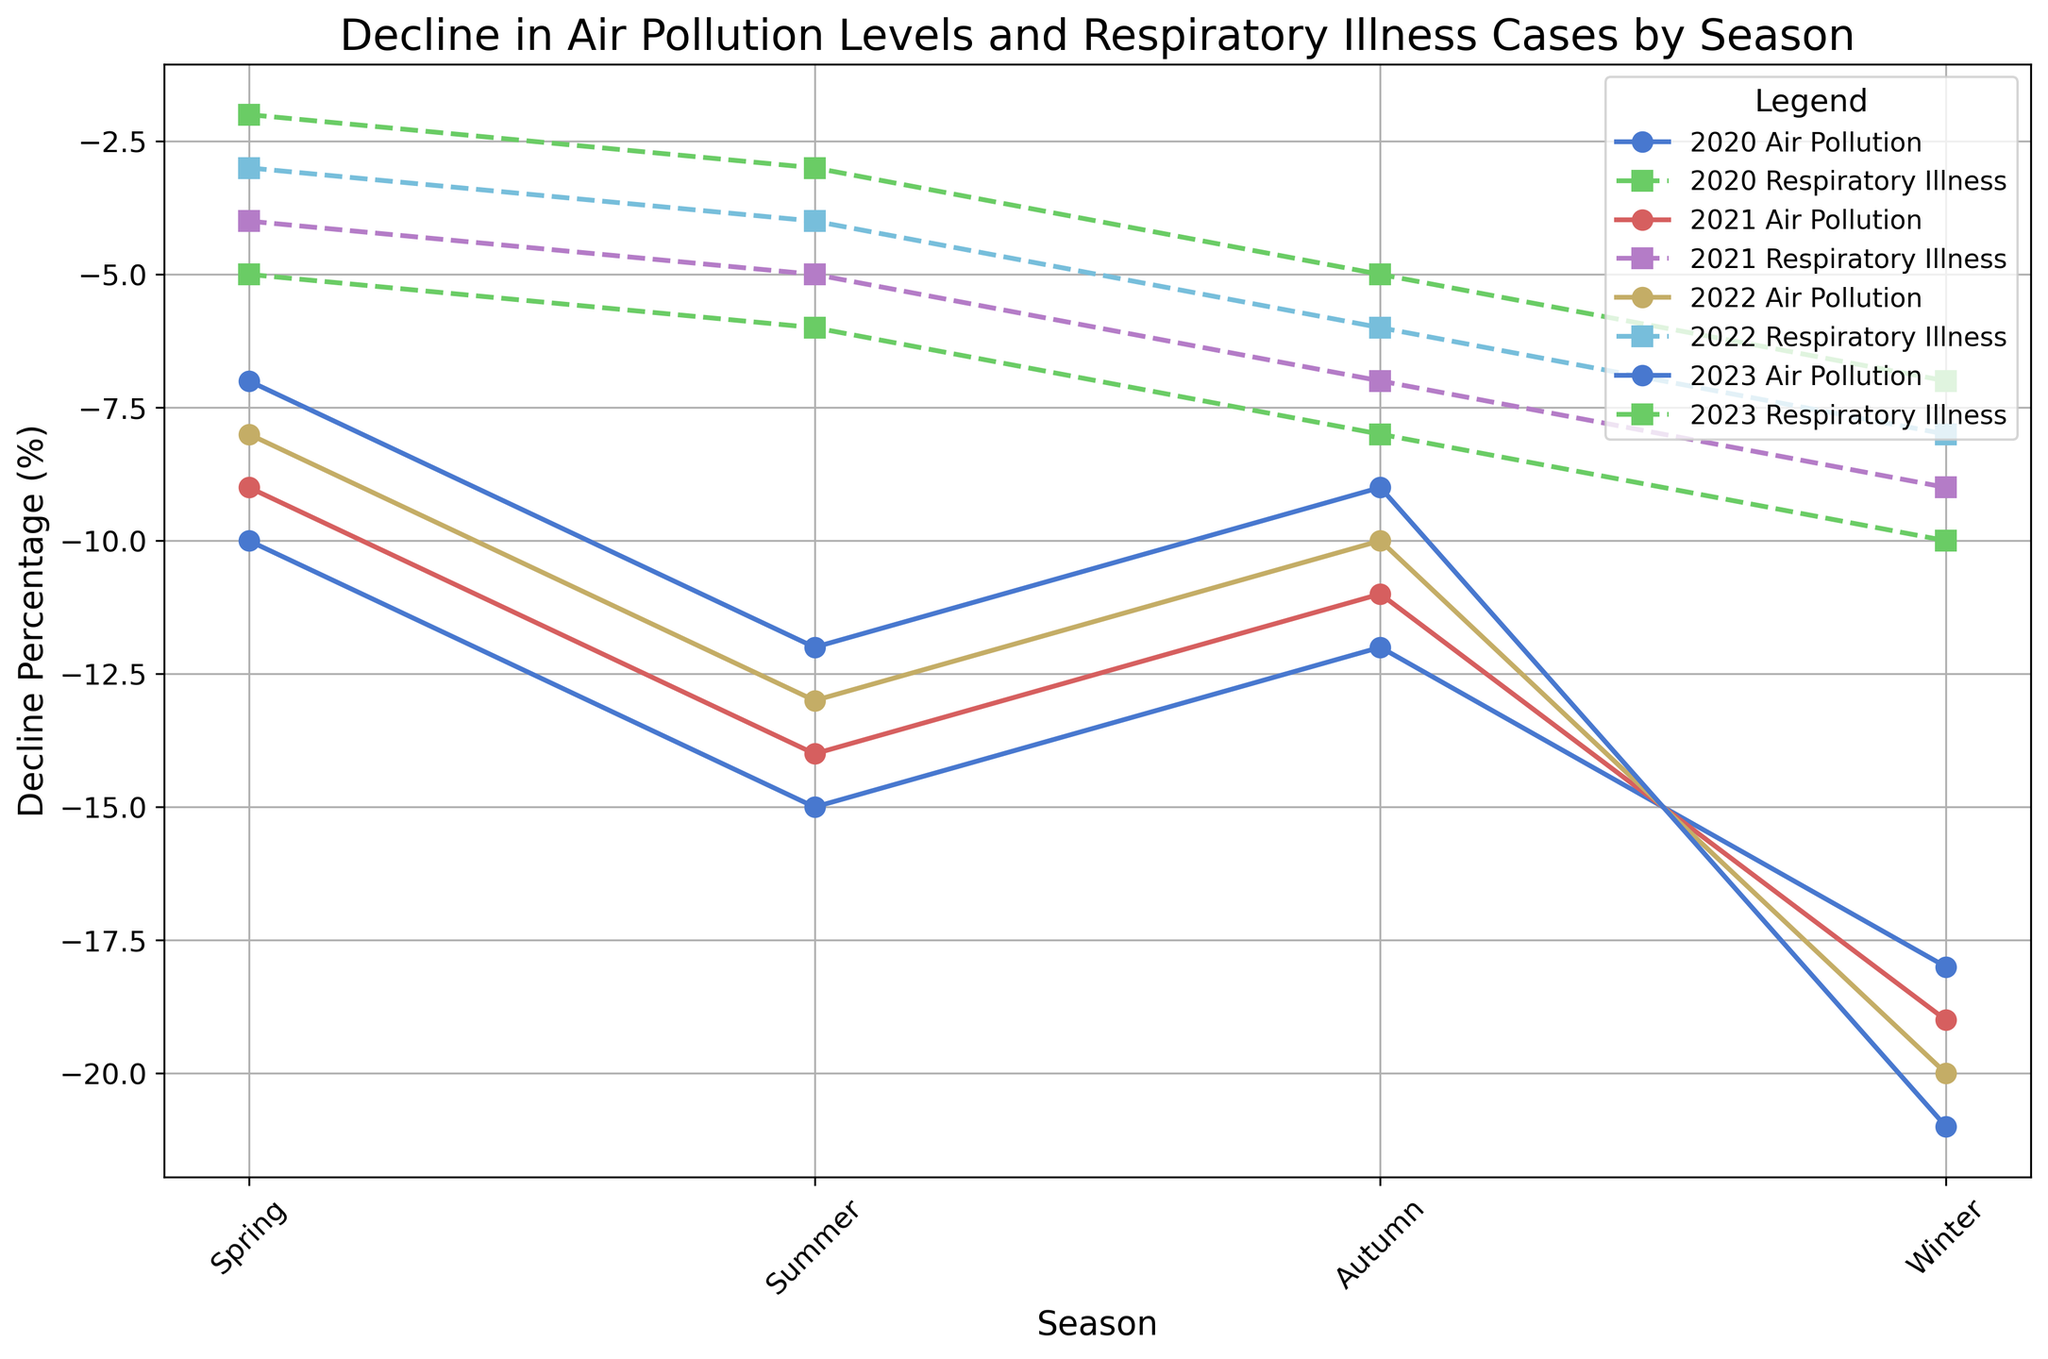What is the largest decline in air pollution levels observed and during which season and year did this occur? To find the largest decline in air pollution, look for the point with the most negative value on the line representing air pollution levels. According to the data, the most negative value for air pollution is -21% during Winter 2023.
Answer: -21% in Winter 2023 Which year shows the smallest overall decline in respiratory illness cases during Spring? Examine the lines representing each year and find the smallest (least negative) decline value for respiratory illness during Spring. For Spring, the smallest decline in respiratory illness cases happened in 2023 with a value of -2%.
Answer: 2023 with -2% How much greater is the decline in respiratory illness cases in Winter 2020 compared to Spring 2020? Identify the decline values in respiratory illness for Winter 2020 and Spring 2020. The decline in Winter 2020 is -10%, and in Spring 2020, it is -5%. The difference is -10% - (-5%) = -10% + 5% = -5%.
Answer: 5% How do the declines in air pollution and respiratory illness cases in Summer 2021 compare? For Summer 2021, check the values for both air pollution (-14%) and respiratory illness (-5%). Compare the magnitude of the declines. The air pollution decline is larger than the respiratory illness cases decline.
Answer: Decline in air pollution is greater (-14% vs. -5%) What is the average decline in respiratory illness cases across all seasons in 2022? Calculate the average of respiratory illness declines for all four seasons in 2022: (-3% + -4% + -6% + -8%) / 4 = -21% / 4 = -5.25%.
Answer: -5.25% Which year shows the highest decline in air pollution during Autumn? Compare the decline values in air pollution during Autumn across all years. The highest decline is -12% in 2020.
Answer: 2020 with -12% In which season and year does the line representing respiratory illness cases show the most significant drop compared to the previous season? Observe the decline in respiratory illness cases by comparing values between adjacent seasons. The largest drop occurred from Summer to Autumn 2020, with a change from -6% to -8%.
Answer: Summer to Autumn 2020 with a drop of -2% Which year had the least variation in the decline of air pollution levels across all seasons? Assess the range of air pollution declines for each year by subtracting the smallest decline from the largest decline within that year. The least variation in air pollution declines is found in 2023, with a range of -7% to -21%.
Answer: 2023, with a variation of 14% 